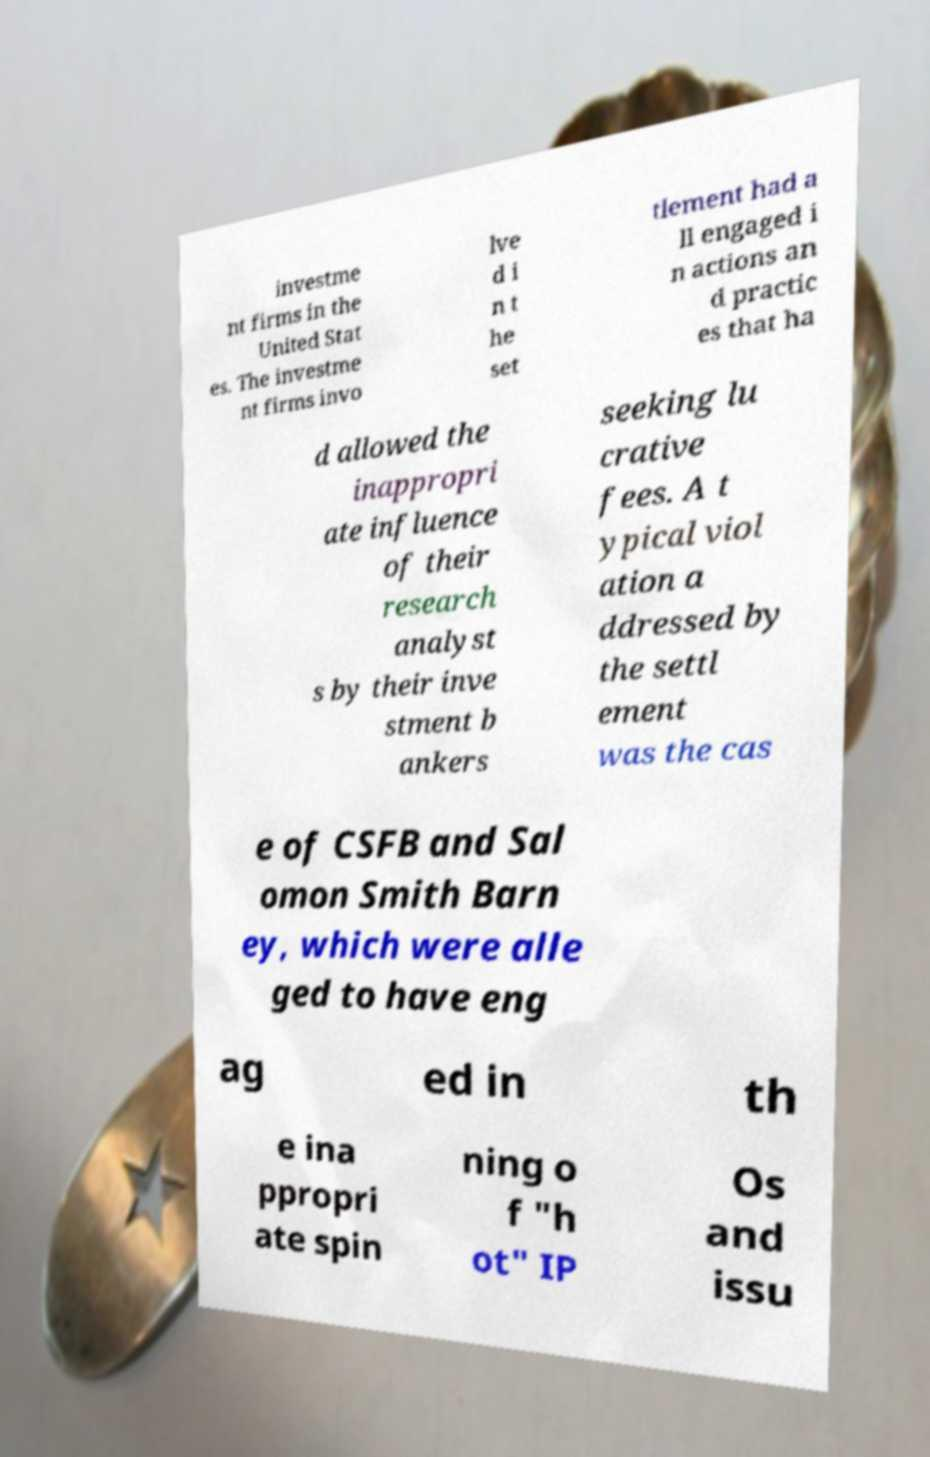For documentation purposes, I need the text within this image transcribed. Could you provide that? investme nt firms in the United Stat es. The investme nt firms invo lve d i n t he set tlement had a ll engaged i n actions an d practic es that ha d allowed the inappropri ate influence of their research analyst s by their inve stment b ankers seeking lu crative fees. A t ypical viol ation a ddressed by the settl ement was the cas e of CSFB and Sal omon Smith Barn ey, which were alle ged to have eng ag ed in th e ina ppropri ate spin ning o f "h ot" IP Os and issu 